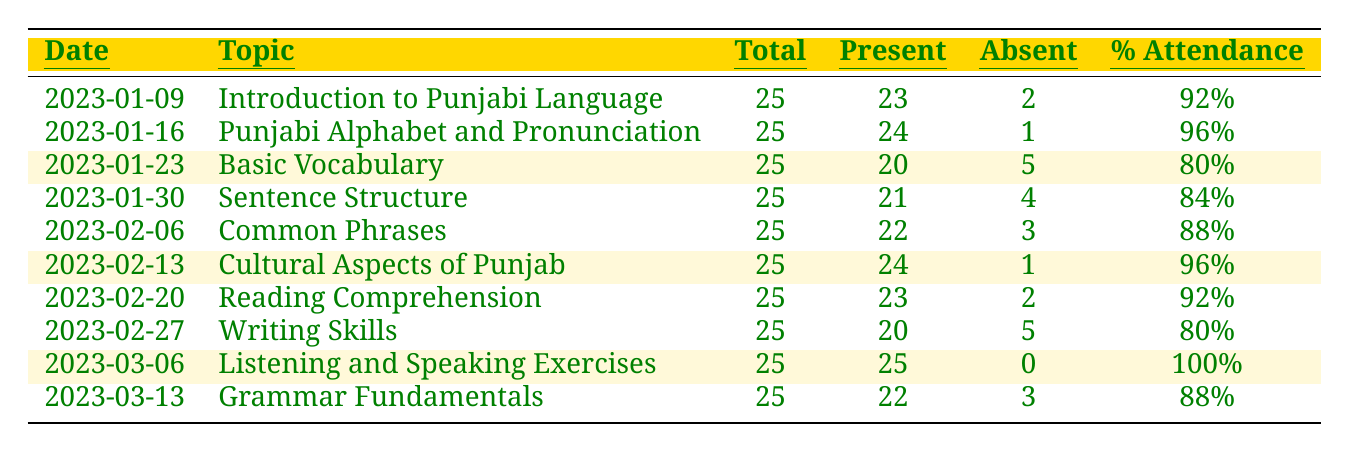What is the date when the highest attendance was recorded? The attendance percentage was highest on 2023-03-06 with 100% present students.
Answer: 2023-03-06 How many students were absent on January 23, 2023? On January 23, 2023, there were 5 absent students indicated in the records.
Answer: 5 What is the total number of present students on February 13, 2023? The total number of present students on February 13, 2023, was 24, as shown in the attendance records.
Answer: 24 Which topic had the lowest percentage of attendance? The topic 'Basic Vocabulary' on January 23, 2023, had the lowest attendance percentage of 80%.
Answer: Basic Vocabulary What was the average attendance percentage for the first four classes? The average attendance percentage for the first four classes can be calculated as (92 + 96 + 80 + 84) / 4 = 88%.
Answer: 88% Did the attendance improve in the class on March 6 compared to the previous week? Yes, the attendance on March 6 was 100%, which was an improvement from 88% the previous week on March 13.
Answer: Yes What is the difference in the number of absent students between the classes on January 23 and January 30? On January 23, there were 5 absent students, and on January 30, there were 4 absent students. The difference is 5 - 4 = 1.
Answer: 1 Which class topic had a higher number of present students: 'Cultural Aspects of Punjab' or 'Common Phrases'? 'Cultural Aspects of Punjab' on February 13 had 24 present students, while 'Common Phrases' on February 6 had 22 present students, making the former higher.
Answer: Cultural Aspects of Punjab What is the total number of students across all recorded classes? The total number of students across all classes is 25 students multiplied by 10 classes, yielding 250 students total.
Answer: 250 How many classes had an attendance percentage above 90%? The classes with attendance percentages above 90% are on January 9, 16, February 13, 20, and March 6, totaling 5 classes.
Answer: 5 